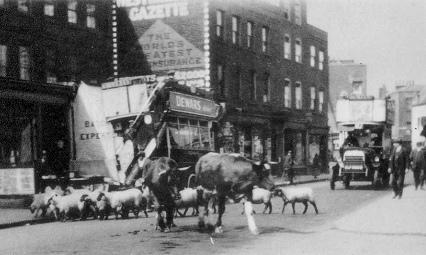What is in front of the vehicle? animals 